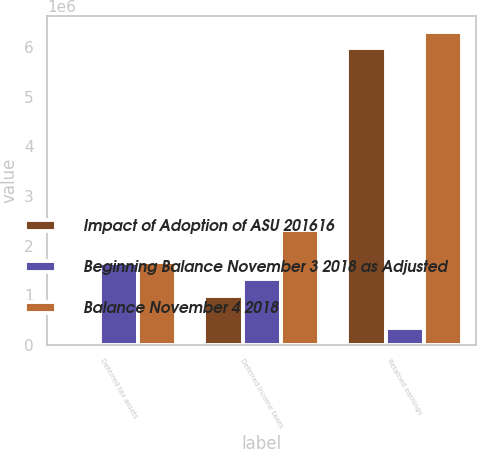<chart> <loc_0><loc_0><loc_500><loc_500><stacked_bar_chart><ecel><fcel>Deferred tax assets<fcel>Deferred income taxes<fcel>Retained earnings<nl><fcel>Impact of Adoption of ASU 201616<fcel>9665<fcel>990409<fcel>5.9827e+06<nl><fcel>Beginning Balance November 3 2018 as Adjusted<fcel>1.65513e+06<fcel>1.3241e+06<fcel>331026<nl><fcel>Balance November 4 2018<fcel>1.66479e+06<fcel>2.31451e+06<fcel>6.31372e+06<nl></chart> 